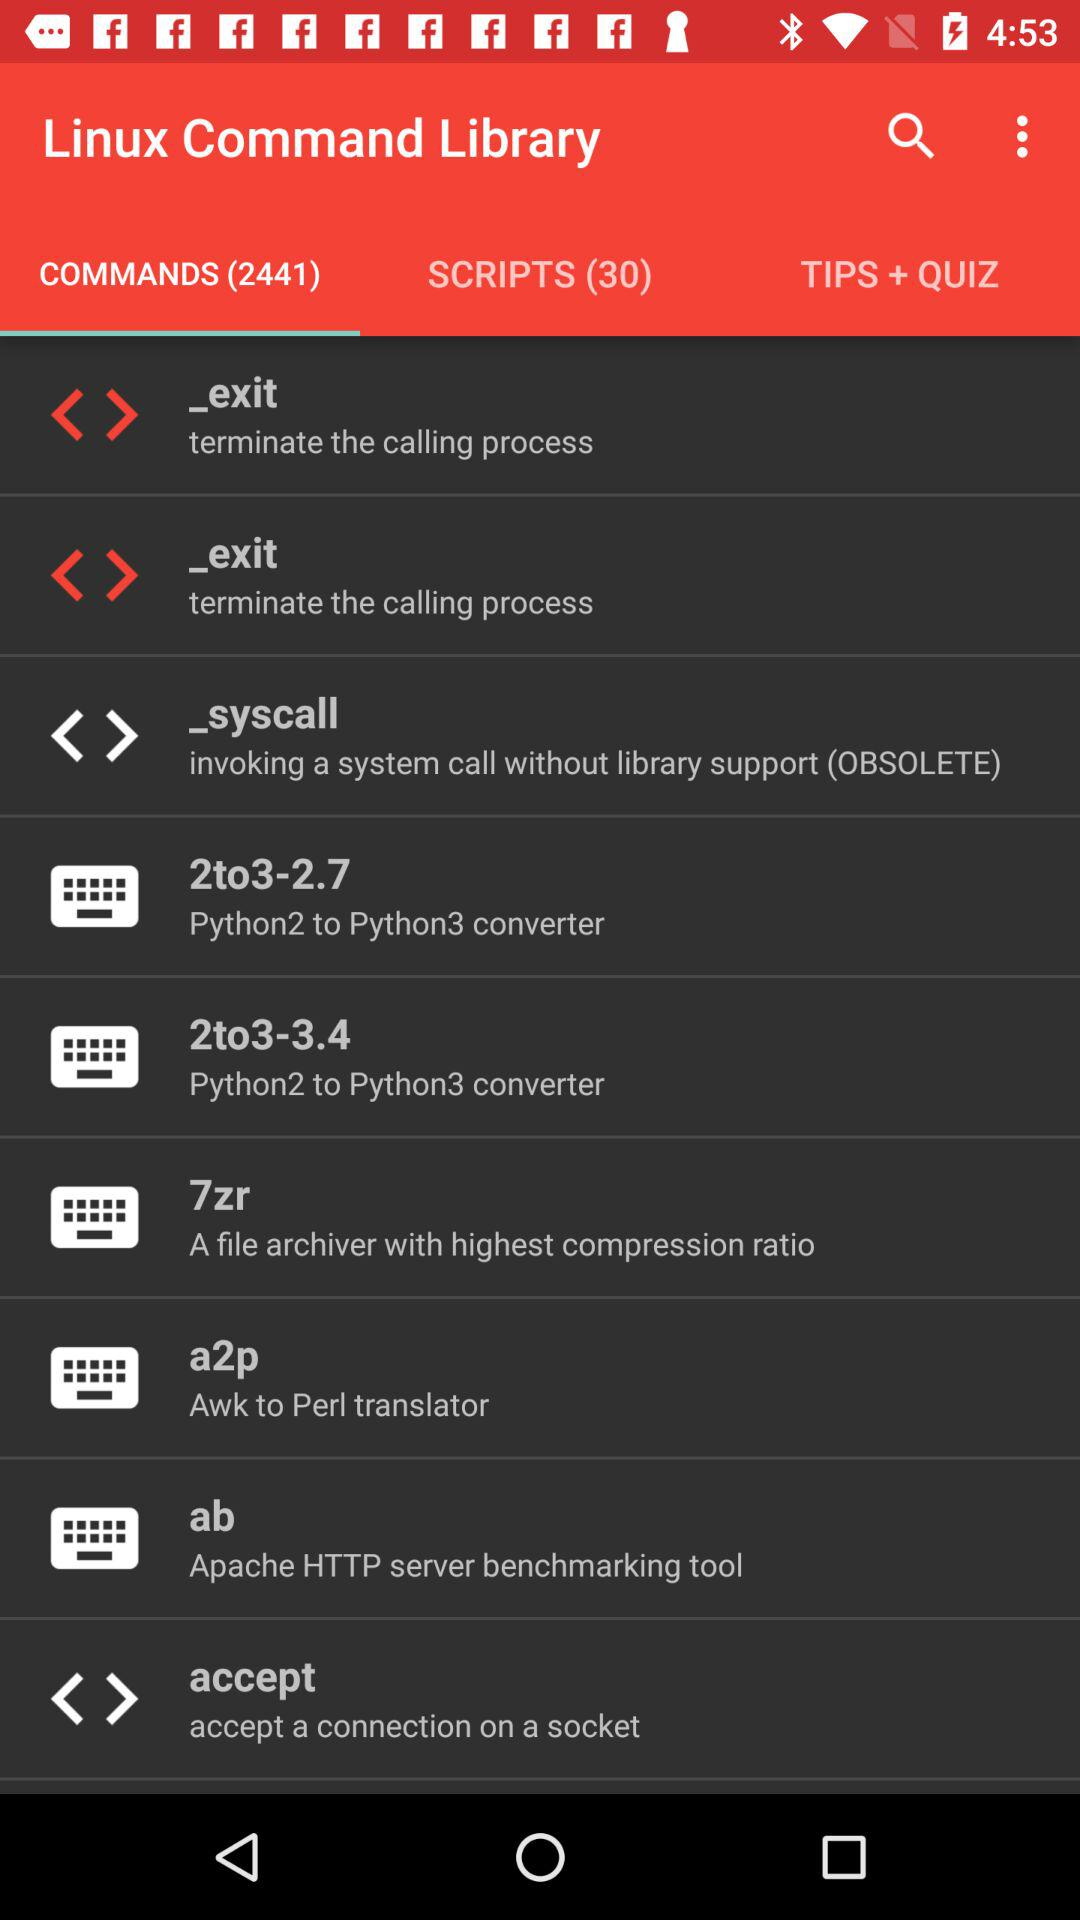How many commands are there in the "Linux Command Library"? There are 2441 commands in the "Linux Command Library". 